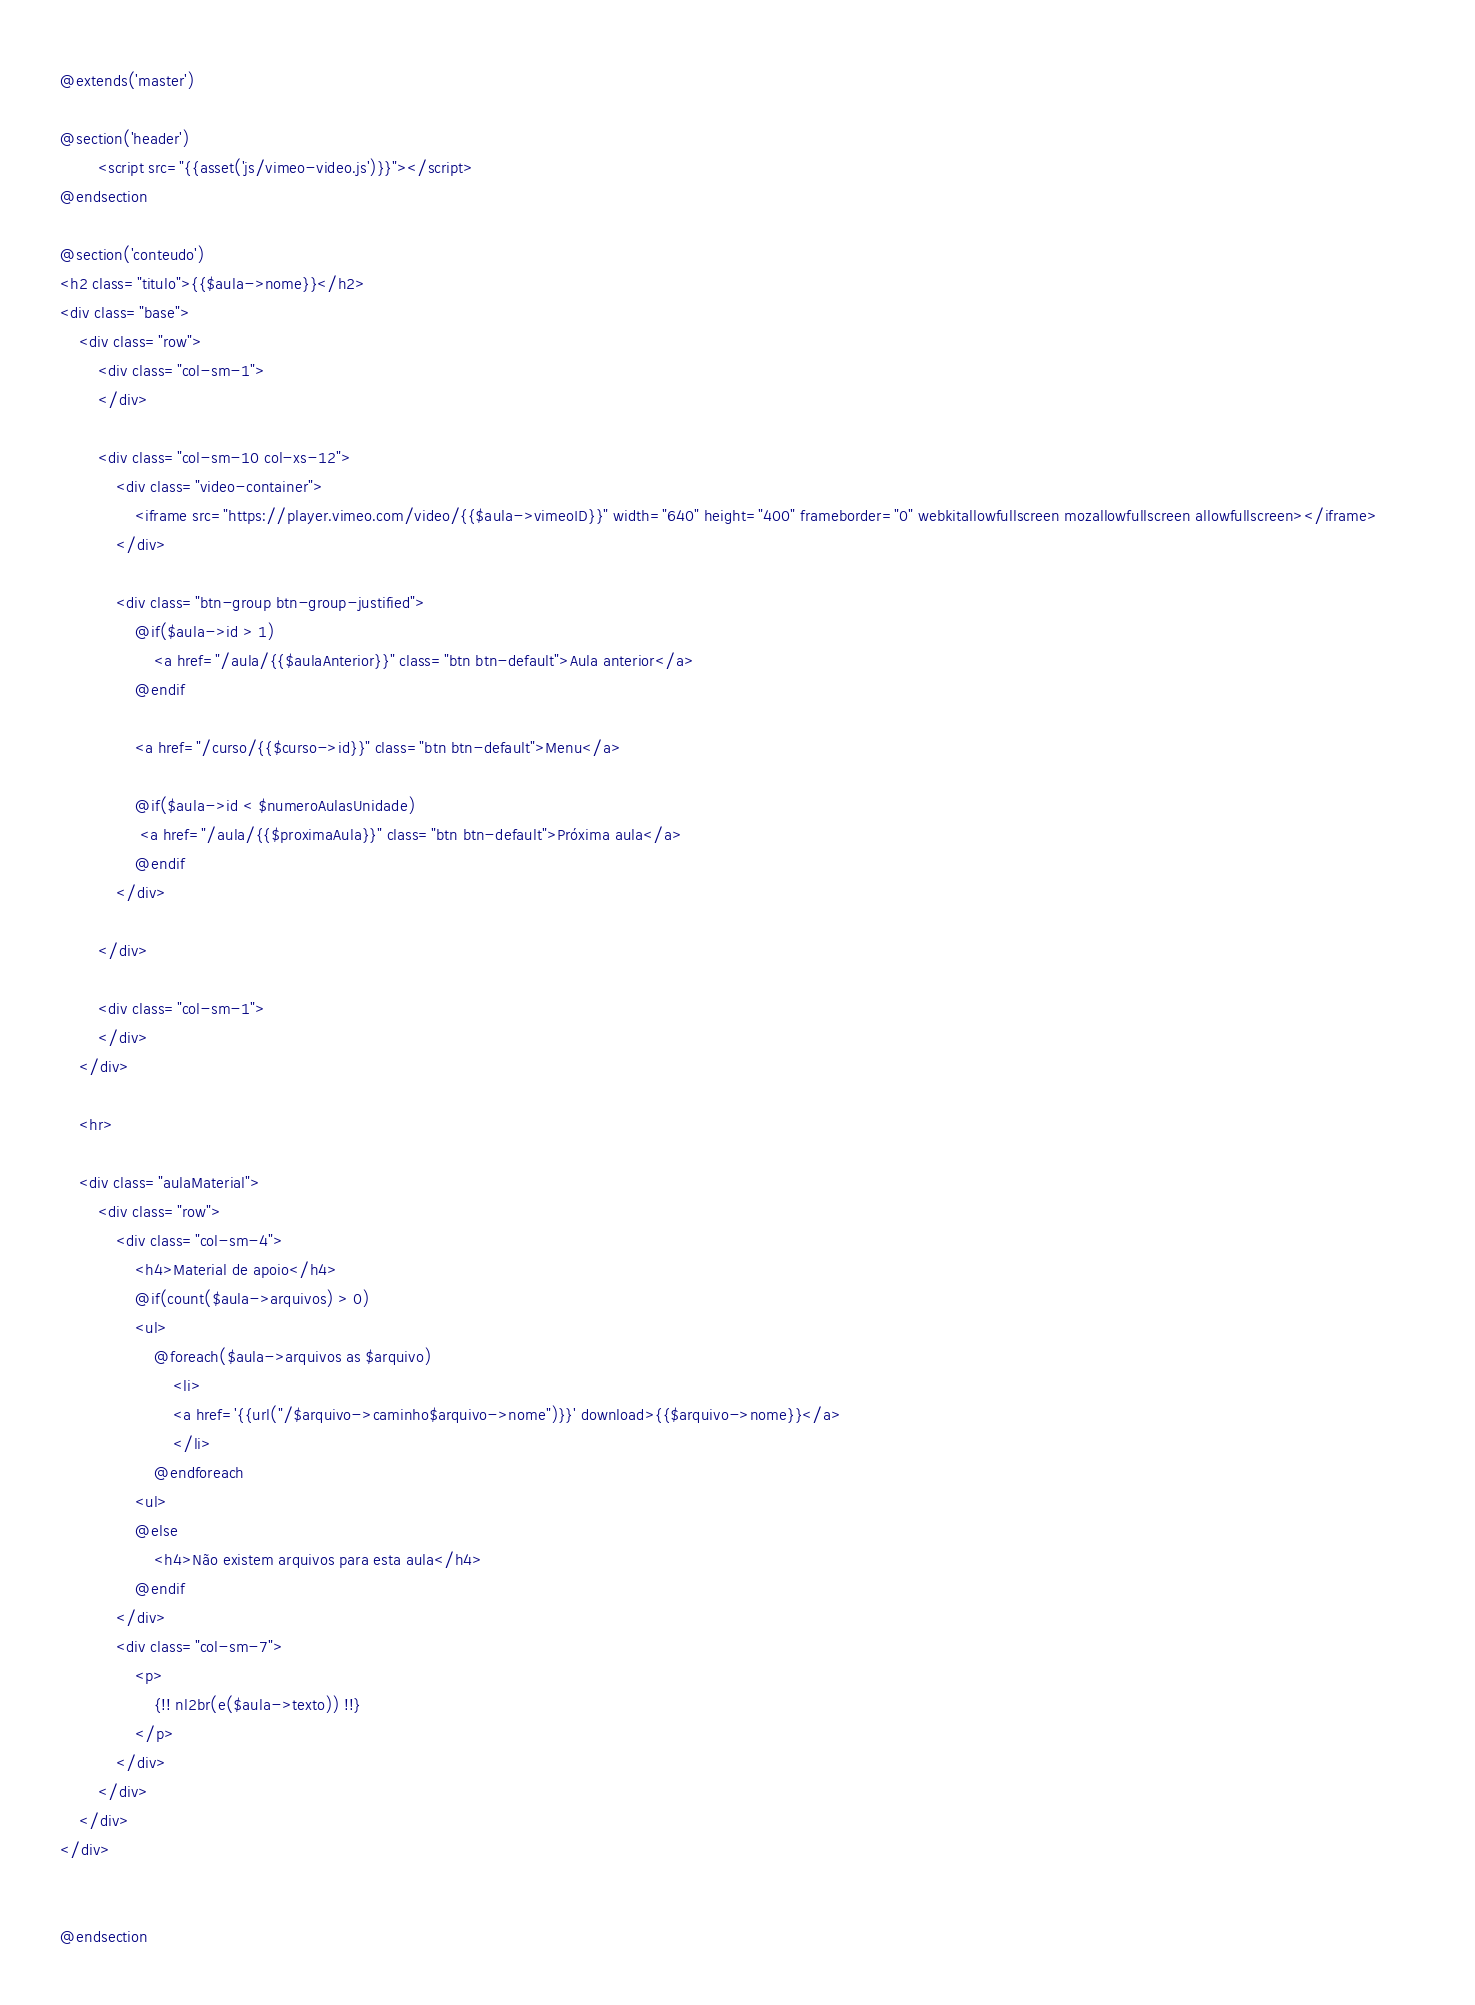Convert code to text. <code><loc_0><loc_0><loc_500><loc_500><_PHP_>@extends('master')

@section('header')
		<script src="{{asset('js/vimeo-video.js')}}"></script>
@endsection

@section('conteudo')
<h2 class="titulo">{{$aula->nome}}</h2>
<div class="base">
	<div class="row">
		<div class="col-sm-1">						
		</div>

		<div class="col-sm-10 col-xs-12">
			<div class="video-container">
				<iframe src="https://player.vimeo.com/video/{{$aula->vimeoID}}" width="640" height="400" frameborder="0" webkitallowfullscreen mozallowfullscreen allowfullscreen></iframe>		
			</div>

			<div class="btn-group btn-group-justified">
				@if($aula->id > 1)
					<a href="/aula/{{$aulaAnterior}}" class="btn btn-default">Aula anterior</a>
				@endif

			    <a href="/curso/{{$curso->id}}" class="btn btn-default">Menu</a>

				@if($aula->id < $numeroAulasUnidade)
				 <a href="/aula/{{$proximaAula}}" class="btn btn-default">Próxima aula</a>
				@endif			  
			</div>

		</div>

		<div class="col-sm-1">			
		</div>
	</div>
	
	<hr>

	<div class="aulaMaterial">
		<div class="row">
			<div class="col-sm-4">
				<h4>Material de apoio</h4>
				@if(count($aula->arquivos) > 0)
				<ul>
                    @foreach($aula->arquivos as $arquivo)
                        <li>
                        <a href='{{url("/$arquivo->caminho$arquivo->nome")}}' download>{{$arquivo->nome}}</a>
                        </li>
                    @endforeach
				<ul>
                @else
                    <h4>Não existem arquivos para esta aula</h4>
                @endif
			</div>
			<div class="col-sm-7">
				<p>
					{!! nl2br(e($aula->texto)) !!}					
				</p>				
			</div>
		</div>
	</div>
</div>


@endsection</code> 